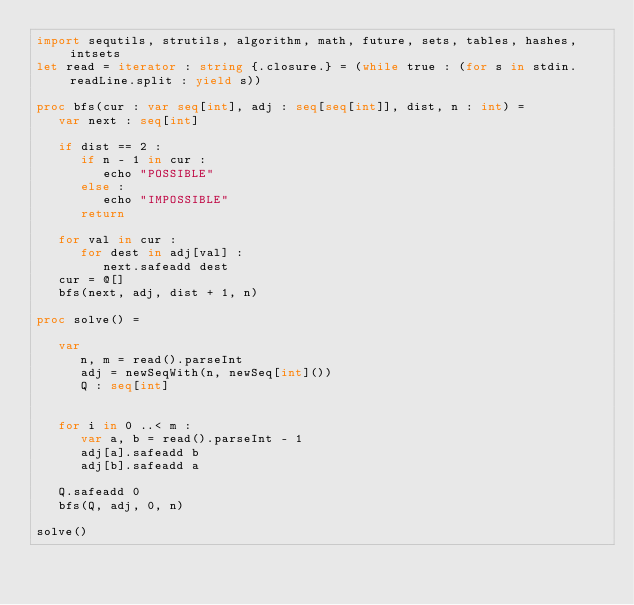Convert code to text. <code><loc_0><loc_0><loc_500><loc_500><_Nim_>import sequtils, strutils, algorithm, math, future, sets, tables, hashes, intsets
let read = iterator : string {.closure.} = (while true : (for s in stdin.readLine.split : yield s))

proc bfs(cur : var seq[int], adj : seq[seq[int]], dist, n : int) = 
   var next : seq[int]

   if dist == 2 : 
      if n - 1 in cur : 
         echo "POSSIBLE"
      else : 
         echo "IMPOSSIBLE"
      return

   for val in cur : 
      for dest in adj[val] : 
         next.safeadd dest
   cur = @[]
   bfs(next, adj, dist + 1, n)

proc solve() =
   
   var
      n, m = read().parseInt
      adj = newSeqWith(n, newSeq[int]())
      Q : seq[int]
      

   for i in 0 ..< m : 
      var a, b = read().parseInt - 1
      adj[a].safeadd b
      adj[b].safeadd a

   Q.safeadd 0
   bfs(Q, adj, 0, n)

solve()</code> 